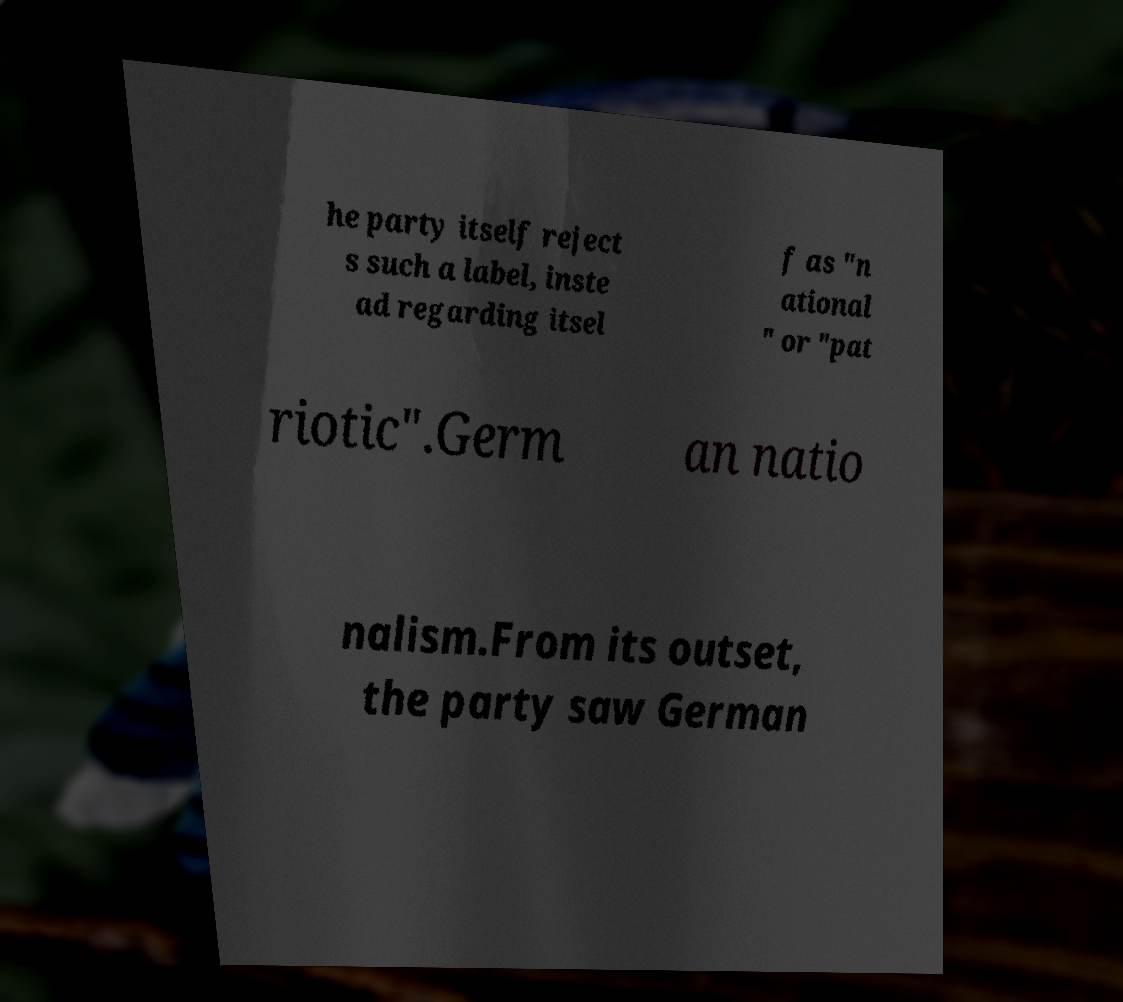Please read and relay the text visible in this image. What does it say? he party itself reject s such a label, inste ad regarding itsel f as "n ational " or "pat riotic".Germ an natio nalism.From its outset, the party saw German 